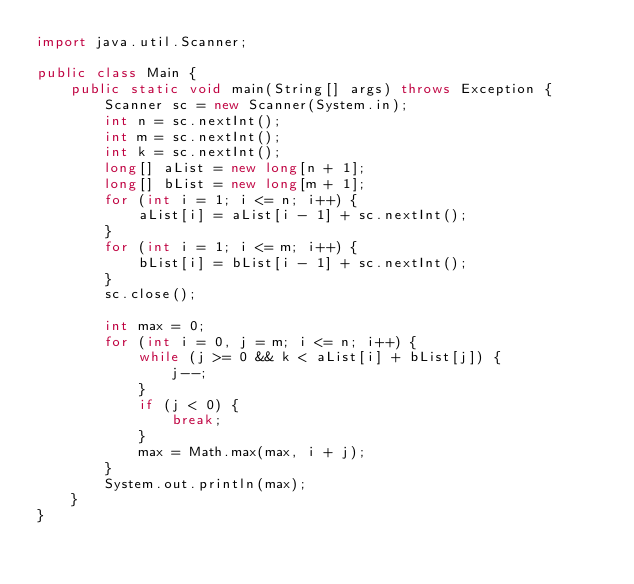Convert code to text. <code><loc_0><loc_0><loc_500><loc_500><_Java_>import java.util.Scanner;

public class Main {
    public static void main(String[] args) throws Exception {
        Scanner sc = new Scanner(System.in);
        int n = sc.nextInt();
        int m = sc.nextInt();
        int k = sc.nextInt();
        long[] aList = new long[n + 1];
        long[] bList = new long[m + 1];
        for (int i = 1; i <= n; i++) {
            aList[i] = aList[i - 1] + sc.nextInt();
        }
        for (int i = 1; i <= m; i++) {
            bList[i] = bList[i - 1] + sc.nextInt();
        }
        sc.close();

        int max = 0;
        for (int i = 0, j = m; i <= n; i++) {
            while (j >= 0 && k < aList[i] + bList[j]) {
                j--;
            }
            if (j < 0) {
                break;
            }
            max = Math.max(max, i + j);
        }
        System.out.println(max);
    }
}
</code> 